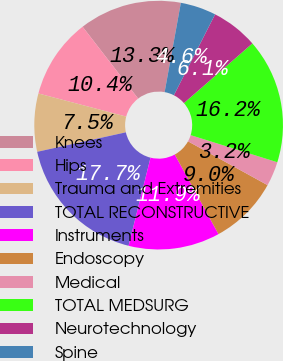Convert chart to OTSL. <chart><loc_0><loc_0><loc_500><loc_500><pie_chart><fcel>Knees<fcel>Hips<fcel>Trauma and Extremities<fcel>TOTAL RECONSTRUCTIVE<fcel>Instruments<fcel>Endoscopy<fcel>Medical<fcel>TOTAL MEDSURG<fcel>Neurotechnology<fcel>Spine<nl><fcel>13.33%<fcel>10.43%<fcel>7.54%<fcel>17.67%<fcel>11.88%<fcel>8.99%<fcel>3.19%<fcel>16.23%<fcel>6.09%<fcel>4.64%<nl></chart> 